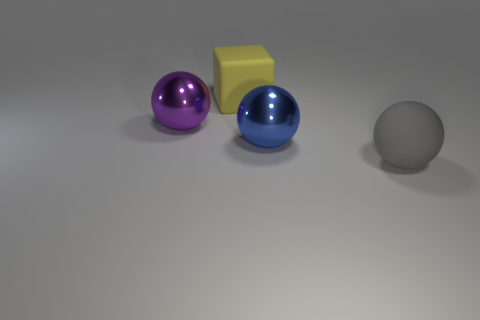Subtract all blue shiny spheres. How many spheres are left? 2 Subtract all gray spheres. How many spheres are left? 2 Subtract 2 balls. How many balls are left? 1 Add 2 matte objects. How many objects exist? 6 Add 4 large purple balls. How many large purple balls are left? 5 Add 4 gray balls. How many gray balls exist? 5 Subtract 0 cyan cylinders. How many objects are left? 4 Subtract all blocks. How many objects are left? 3 Subtract all yellow balls. Subtract all red blocks. How many balls are left? 3 Subtract all cyan cubes. How many purple spheres are left? 1 